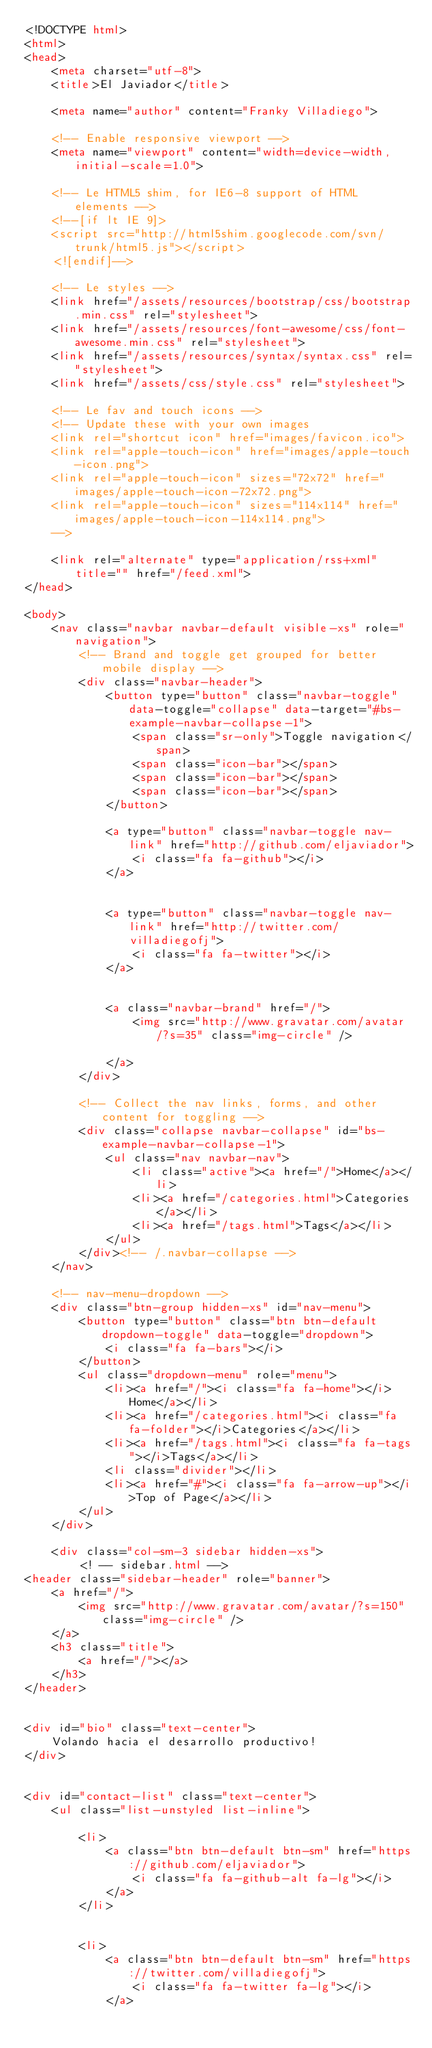<code> <loc_0><loc_0><loc_500><loc_500><_HTML_><!DOCTYPE html>
<html>
<head>
	<meta charset="utf-8">
	<title>El Javiador</title>
	
	<meta name="author" content="Franky Villadiego">

	<!-- Enable responsive viewport -->
	<meta name="viewport" content="width=device-width, initial-scale=1.0">

	<!-- Le HTML5 shim, for IE6-8 support of HTML elements -->
	<!--[if lt IE 9]>
	<script src="http://html5shim.googlecode.com/svn/trunk/html5.js"></script>
	<![endif]-->

	<!-- Le styles -->
	<link href="/assets/resources/bootstrap/css/bootstrap.min.css" rel="stylesheet">
	<link href="/assets/resources/font-awesome/css/font-awesome.min.css" rel="stylesheet">
	<link href="/assets/resources/syntax/syntax.css" rel="stylesheet">
	<link href="/assets/css/style.css" rel="stylesheet">

	<!-- Le fav and touch icons -->
	<!-- Update these with your own images
	<link rel="shortcut icon" href="images/favicon.ico">
	<link rel="apple-touch-icon" href="images/apple-touch-icon.png">
	<link rel="apple-touch-icon" sizes="72x72" href="images/apple-touch-icon-72x72.png">
	<link rel="apple-touch-icon" sizes="114x114" href="images/apple-touch-icon-114x114.png">
	-->

	<link rel="alternate" type="application/rss+xml" title="" href="/feed.xml">
</head>

<body>
	<nav class="navbar navbar-default visible-xs" role="navigation">
		<!-- Brand and toggle get grouped for better mobile display -->
		<div class="navbar-header">
			<button type="button" class="navbar-toggle" data-toggle="collapse" data-target="#bs-example-navbar-collapse-1">
				<span class="sr-only">Toggle navigation</span>
				<span class="icon-bar"></span>
				<span class="icon-bar"></span>
				<span class="icon-bar"></span>
			</button>
			
			<a type="button" class="navbar-toggle nav-link" href="http://github.com/eljaviador">
				<i class="fa fa-github"></i>
			</a>
			
			
			<a type="button" class="navbar-toggle nav-link" href="http://twitter.com/villadiegofj">
				<i class="fa fa-twitter"></i>
			</a>
			
			
			<a class="navbar-brand" href="/">
				<img src="http://www.gravatar.com/avatar/?s=35" class="img-circle" />
				
			</a>
		</div>

		<!-- Collect the nav links, forms, and other content for toggling -->
		<div class="collapse navbar-collapse" id="bs-example-navbar-collapse-1">
			<ul class="nav navbar-nav">
				<li class="active"><a href="/">Home</a></li>
				<li><a href="/categories.html">Categories</a></li>
				<li><a href="/tags.html">Tags</a></li>
			</ul>
		</div><!-- /.navbar-collapse -->
	</nav>

	<!-- nav-menu-dropdown -->
	<div class="btn-group hidden-xs" id="nav-menu">
		<button type="button" class="btn btn-default dropdown-toggle" data-toggle="dropdown">
			<i class="fa fa-bars"></i>
		</button>
		<ul class="dropdown-menu" role="menu">
			<li><a href="/"><i class="fa fa-home"></i>Home</a></li>
			<li><a href="/categories.html"><i class="fa fa-folder"></i>Categories</a></li>
			<li><a href="/tags.html"><i class="fa fa-tags"></i>Tags</a></li>
			<li class="divider"></li>
			<li><a href="#"><i class="fa fa-arrow-up"></i>Top of Page</a></li>
		</ul>
	</div>

	<div class="col-sm-3 sidebar hidden-xs">
		<! -- sidebar.html -->
<header class="sidebar-header" role="banner">
	<a href="/">
		<img src="http://www.gravatar.com/avatar/?s=150" class="img-circle" />
	</a>
	<h3 class="title">
        <a href="/"></a>
    </h3>
</header>


<div id="bio" class="text-center">
	Volando hacia el desarrollo productivo!
</div>


<div id="contact-list" class="text-center">
	<ul class="list-unstyled list-inline">
		
		<li>
			<a class="btn btn-default btn-sm" href="https://github.com/eljaviador">
				<i class="fa fa-github-alt fa-lg"></i>
			</a>
		</li>
		
		
		<li>
			<a class="btn btn-default btn-sm" href="https://twitter.com/villadiegofj">
				<i class="fa fa-twitter fa-lg"></i>
			</a></code> 